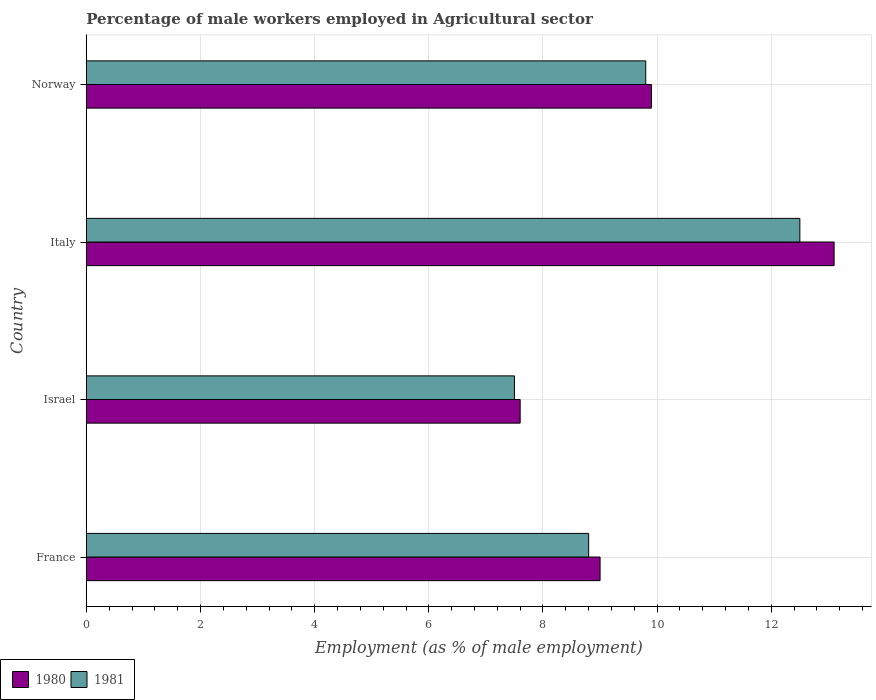How many different coloured bars are there?
Your answer should be compact. 2. How many bars are there on the 1st tick from the top?
Provide a short and direct response. 2. What is the label of the 3rd group of bars from the top?
Offer a very short reply. Israel. What is the percentage of male workers employed in Agricultural sector in 1980 in Israel?
Provide a succinct answer. 7.6. Across all countries, what is the minimum percentage of male workers employed in Agricultural sector in 1980?
Provide a succinct answer. 7.6. What is the total percentage of male workers employed in Agricultural sector in 1981 in the graph?
Make the answer very short. 38.6. What is the difference between the percentage of male workers employed in Agricultural sector in 1980 in Israel and the percentage of male workers employed in Agricultural sector in 1981 in Norway?
Keep it short and to the point. -2.2. What is the average percentage of male workers employed in Agricultural sector in 1981 per country?
Offer a very short reply. 9.65. What is the difference between the percentage of male workers employed in Agricultural sector in 1980 and percentage of male workers employed in Agricultural sector in 1981 in Norway?
Your response must be concise. 0.1. What is the ratio of the percentage of male workers employed in Agricultural sector in 1980 in France to that in Norway?
Provide a succinct answer. 0.91. Is the difference between the percentage of male workers employed in Agricultural sector in 1980 in Israel and Italy greater than the difference between the percentage of male workers employed in Agricultural sector in 1981 in Israel and Italy?
Your answer should be compact. No. What is the difference between the highest and the second highest percentage of male workers employed in Agricultural sector in 1981?
Your answer should be very brief. 2.7. What is the difference between the highest and the lowest percentage of male workers employed in Agricultural sector in 1980?
Keep it short and to the point. 5.5. In how many countries, is the percentage of male workers employed in Agricultural sector in 1980 greater than the average percentage of male workers employed in Agricultural sector in 1980 taken over all countries?
Offer a very short reply. 1. Is the sum of the percentage of male workers employed in Agricultural sector in 1980 in Italy and Norway greater than the maximum percentage of male workers employed in Agricultural sector in 1981 across all countries?
Offer a very short reply. Yes. Are all the bars in the graph horizontal?
Provide a succinct answer. Yes. Does the graph contain any zero values?
Your answer should be very brief. No. Does the graph contain grids?
Your answer should be compact. Yes. Where does the legend appear in the graph?
Give a very brief answer. Bottom left. How many legend labels are there?
Provide a succinct answer. 2. What is the title of the graph?
Keep it short and to the point. Percentage of male workers employed in Agricultural sector. Does "2003" appear as one of the legend labels in the graph?
Provide a short and direct response. No. What is the label or title of the X-axis?
Give a very brief answer. Employment (as % of male employment). What is the label or title of the Y-axis?
Ensure brevity in your answer.  Country. What is the Employment (as % of male employment) in 1981 in France?
Your response must be concise. 8.8. What is the Employment (as % of male employment) in 1980 in Israel?
Offer a terse response. 7.6. What is the Employment (as % of male employment) of 1981 in Israel?
Your answer should be very brief. 7.5. What is the Employment (as % of male employment) in 1980 in Italy?
Your answer should be compact. 13.1. What is the Employment (as % of male employment) of 1981 in Italy?
Ensure brevity in your answer.  12.5. What is the Employment (as % of male employment) of 1980 in Norway?
Your answer should be very brief. 9.9. What is the Employment (as % of male employment) in 1981 in Norway?
Your answer should be compact. 9.8. Across all countries, what is the maximum Employment (as % of male employment) in 1980?
Offer a terse response. 13.1. Across all countries, what is the minimum Employment (as % of male employment) of 1980?
Your response must be concise. 7.6. Across all countries, what is the minimum Employment (as % of male employment) in 1981?
Ensure brevity in your answer.  7.5. What is the total Employment (as % of male employment) of 1980 in the graph?
Ensure brevity in your answer.  39.6. What is the total Employment (as % of male employment) of 1981 in the graph?
Offer a terse response. 38.6. What is the difference between the Employment (as % of male employment) of 1980 in France and that in Israel?
Provide a succinct answer. 1.4. What is the difference between the Employment (as % of male employment) of 1980 in France and that in Italy?
Your answer should be compact. -4.1. What is the difference between the Employment (as % of male employment) of 1981 in France and that in Italy?
Your response must be concise. -3.7. What is the difference between the Employment (as % of male employment) in 1980 in France and that in Norway?
Your answer should be very brief. -0.9. What is the difference between the Employment (as % of male employment) in 1980 in Israel and that in Norway?
Make the answer very short. -2.3. What is the difference between the Employment (as % of male employment) of 1981 in Israel and that in Norway?
Your answer should be compact. -2.3. What is the difference between the Employment (as % of male employment) in 1981 in Italy and that in Norway?
Give a very brief answer. 2.7. What is the difference between the Employment (as % of male employment) of 1980 in Israel and the Employment (as % of male employment) of 1981 in Italy?
Make the answer very short. -4.9. What is the difference between the Employment (as % of male employment) in 1980 in Israel and the Employment (as % of male employment) in 1981 in Norway?
Offer a very short reply. -2.2. What is the average Employment (as % of male employment) of 1980 per country?
Ensure brevity in your answer.  9.9. What is the average Employment (as % of male employment) in 1981 per country?
Provide a short and direct response. 9.65. What is the difference between the Employment (as % of male employment) of 1980 and Employment (as % of male employment) of 1981 in Norway?
Give a very brief answer. 0.1. What is the ratio of the Employment (as % of male employment) in 1980 in France to that in Israel?
Provide a short and direct response. 1.18. What is the ratio of the Employment (as % of male employment) of 1981 in France to that in Israel?
Make the answer very short. 1.17. What is the ratio of the Employment (as % of male employment) of 1980 in France to that in Italy?
Ensure brevity in your answer.  0.69. What is the ratio of the Employment (as % of male employment) in 1981 in France to that in Italy?
Offer a terse response. 0.7. What is the ratio of the Employment (as % of male employment) in 1980 in France to that in Norway?
Give a very brief answer. 0.91. What is the ratio of the Employment (as % of male employment) of 1981 in France to that in Norway?
Ensure brevity in your answer.  0.9. What is the ratio of the Employment (as % of male employment) of 1980 in Israel to that in Italy?
Your answer should be very brief. 0.58. What is the ratio of the Employment (as % of male employment) in 1980 in Israel to that in Norway?
Your answer should be very brief. 0.77. What is the ratio of the Employment (as % of male employment) of 1981 in Israel to that in Norway?
Offer a terse response. 0.77. What is the ratio of the Employment (as % of male employment) in 1980 in Italy to that in Norway?
Make the answer very short. 1.32. What is the ratio of the Employment (as % of male employment) of 1981 in Italy to that in Norway?
Your answer should be compact. 1.28. What is the difference between the highest and the lowest Employment (as % of male employment) in 1981?
Offer a very short reply. 5. 